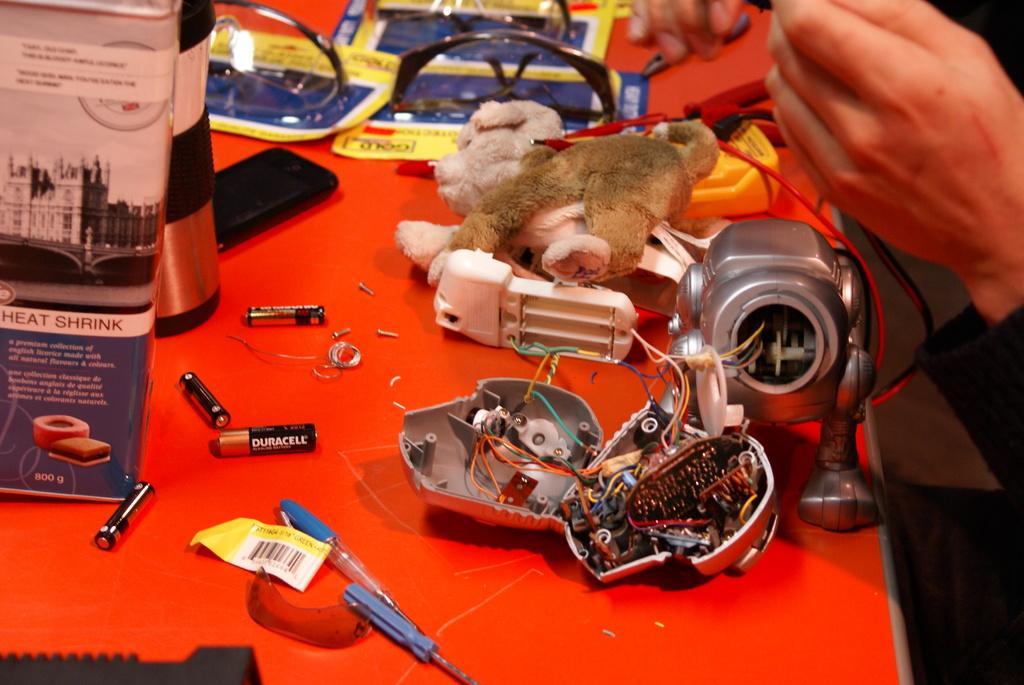Please provide a concise description of this image. In this image there is a pen, four batteries, a mobile phone, toy, glasses, papers and a book. These items are placed on the red table. We can also see some persons hand and the person is repairing an object. 